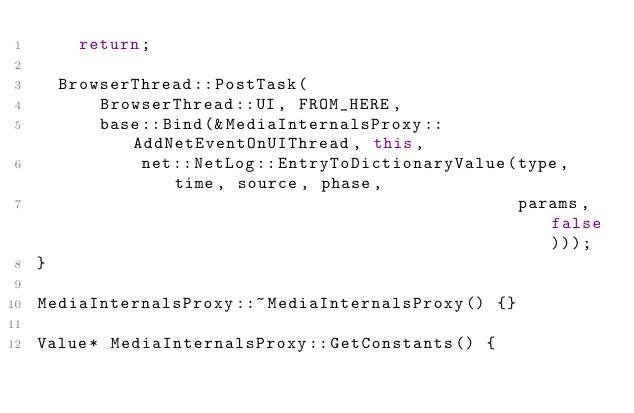<code> <loc_0><loc_0><loc_500><loc_500><_C++_>    return;

  BrowserThread::PostTask(
      BrowserThread::UI, FROM_HERE,
      base::Bind(&MediaInternalsProxy::AddNetEventOnUIThread, this,
          net::NetLog::EntryToDictionaryValue(type, time, source, phase,
                                              params, false)));
}

MediaInternalsProxy::~MediaInternalsProxy() {}

Value* MediaInternalsProxy::GetConstants() {</code> 